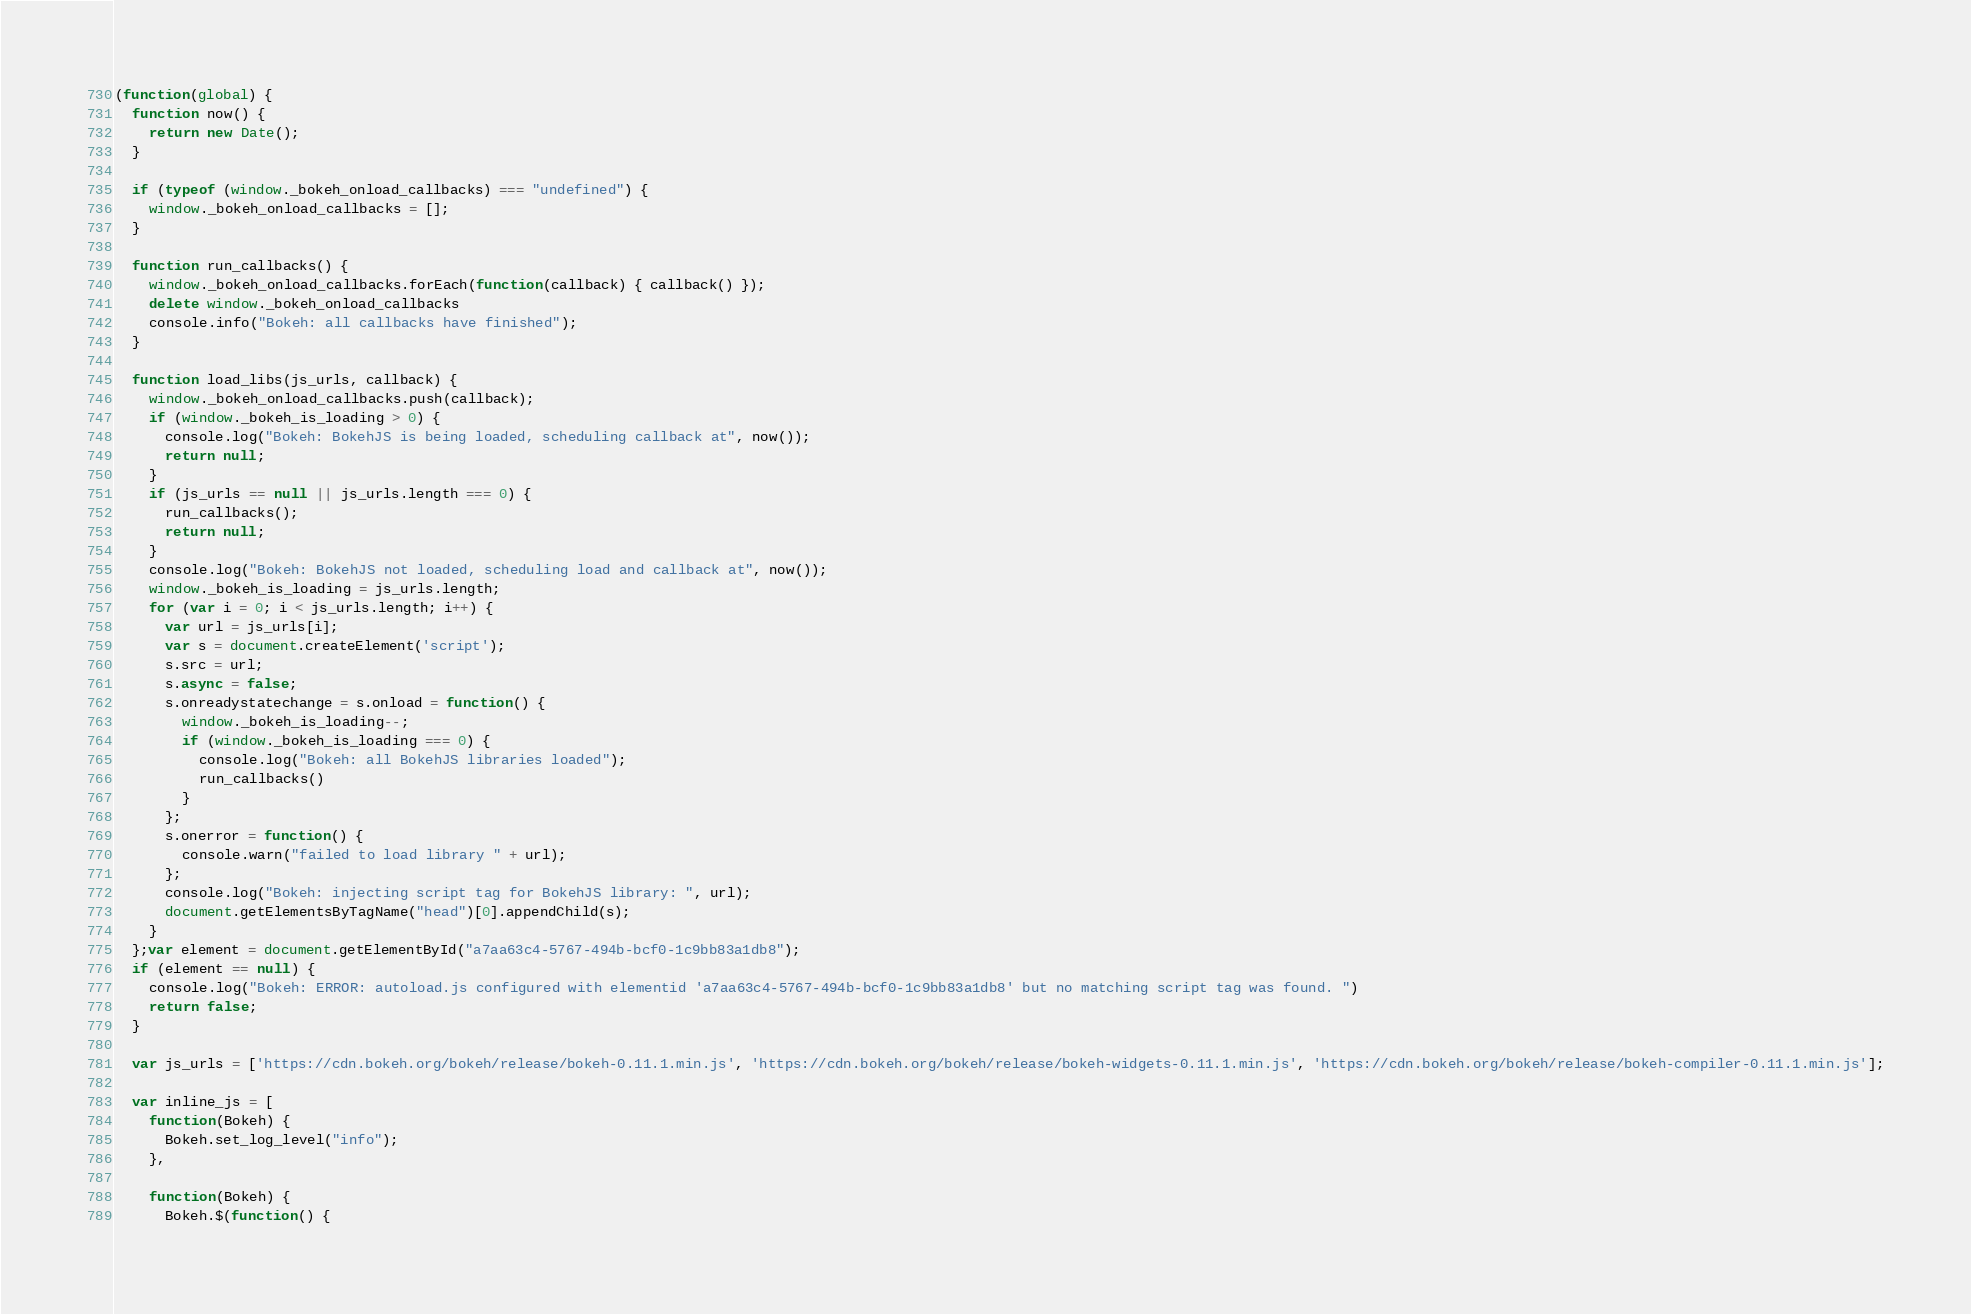<code> <loc_0><loc_0><loc_500><loc_500><_JavaScript_>
(function(global) {
  function now() {
    return new Date();
  }

  if (typeof (window._bokeh_onload_callbacks) === "undefined") {
    window._bokeh_onload_callbacks = [];
  }

  function run_callbacks() {
    window._bokeh_onload_callbacks.forEach(function(callback) { callback() });
    delete window._bokeh_onload_callbacks
    console.info("Bokeh: all callbacks have finished");
  }

  function load_libs(js_urls, callback) {
    window._bokeh_onload_callbacks.push(callback);
    if (window._bokeh_is_loading > 0) {
      console.log("Bokeh: BokehJS is being loaded, scheduling callback at", now());
      return null;
    }
    if (js_urls == null || js_urls.length === 0) {
      run_callbacks();
      return null;
    }
    console.log("Bokeh: BokehJS not loaded, scheduling load and callback at", now());
    window._bokeh_is_loading = js_urls.length;
    for (var i = 0; i < js_urls.length; i++) {
      var url = js_urls[i];
      var s = document.createElement('script');
      s.src = url;
      s.async = false;
      s.onreadystatechange = s.onload = function() {
        window._bokeh_is_loading--;
        if (window._bokeh_is_loading === 0) {
          console.log("Bokeh: all BokehJS libraries loaded");
          run_callbacks()
        }
      };
      s.onerror = function() {
        console.warn("failed to load library " + url);
      };
      console.log("Bokeh: injecting script tag for BokehJS library: ", url);
      document.getElementsByTagName("head")[0].appendChild(s);
    }
  };var element = document.getElementById("a7aa63c4-5767-494b-bcf0-1c9bb83a1db8");
  if (element == null) {
    console.log("Bokeh: ERROR: autoload.js configured with elementid 'a7aa63c4-5767-494b-bcf0-1c9bb83a1db8' but no matching script tag was found. ")
    return false;
  }

  var js_urls = ['https://cdn.bokeh.org/bokeh/release/bokeh-0.11.1.min.js', 'https://cdn.bokeh.org/bokeh/release/bokeh-widgets-0.11.1.min.js', 'https://cdn.bokeh.org/bokeh/release/bokeh-compiler-0.11.1.min.js'];

  var inline_js = [
    function(Bokeh) {
      Bokeh.set_log_level("info");
    },
    
    function(Bokeh) {
      Bokeh.$(function() {</code> 